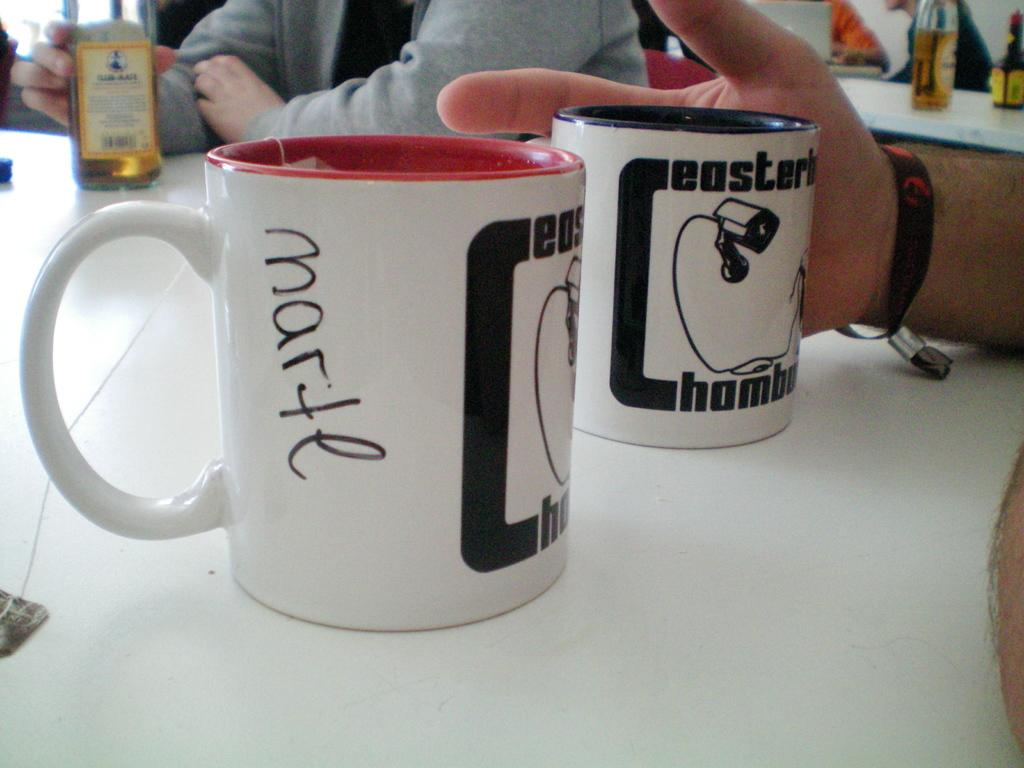Provide a one-sentence caption for the provided image. A cup with the word Marte written on it is on a table next to another cup. 